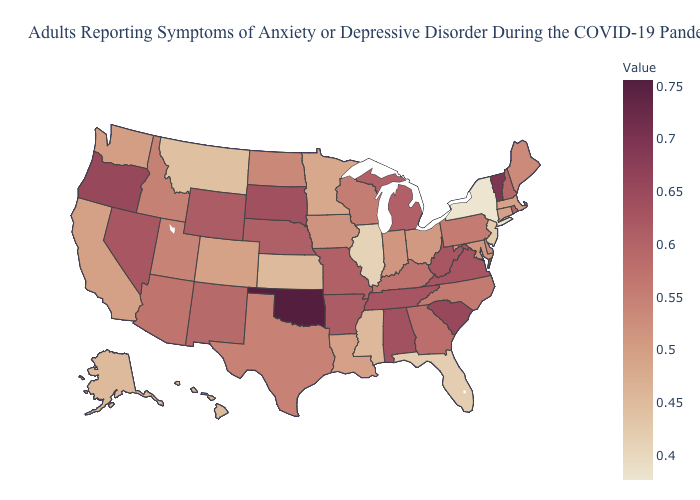Among the states that border New York , which have the highest value?
Quick response, please. Vermont. Does New York have the lowest value in the USA?
Concise answer only. Yes. Does Oregon have the highest value in the West?
Be succinct. Yes. Among the states that border Washington , which have the highest value?
Short answer required. Oregon. 